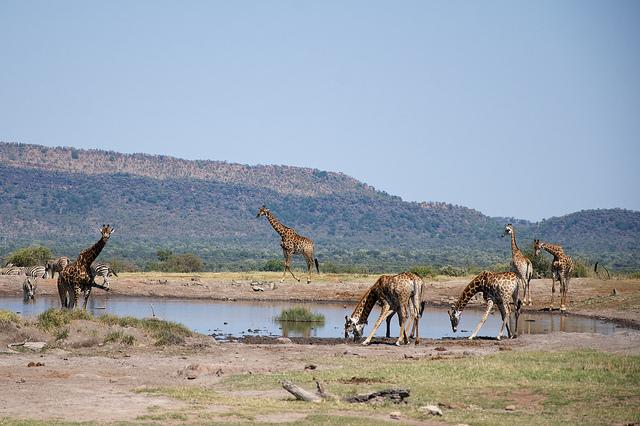How many of the giraffes are taking a drink in the water?

Choices:
A) six
B) one
C) four
D) three six 